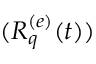Convert formula to latex. <formula><loc_0><loc_0><loc_500><loc_500>( R _ { q } ^ { ( e ) } ( t ) )</formula> 